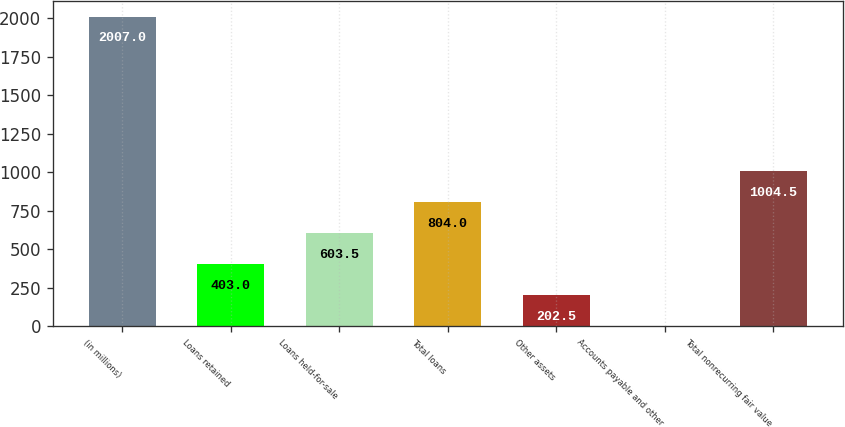Convert chart. <chart><loc_0><loc_0><loc_500><loc_500><bar_chart><fcel>(in millions)<fcel>Loans retained<fcel>Loans held-for-sale<fcel>Total loans<fcel>Other assets<fcel>Accounts payable and other<fcel>Total nonrecurring fair value<nl><fcel>2007<fcel>403<fcel>603.5<fcel>804<fcel>202.5<fcel>2<fcel>1004.5<nl></chart> 